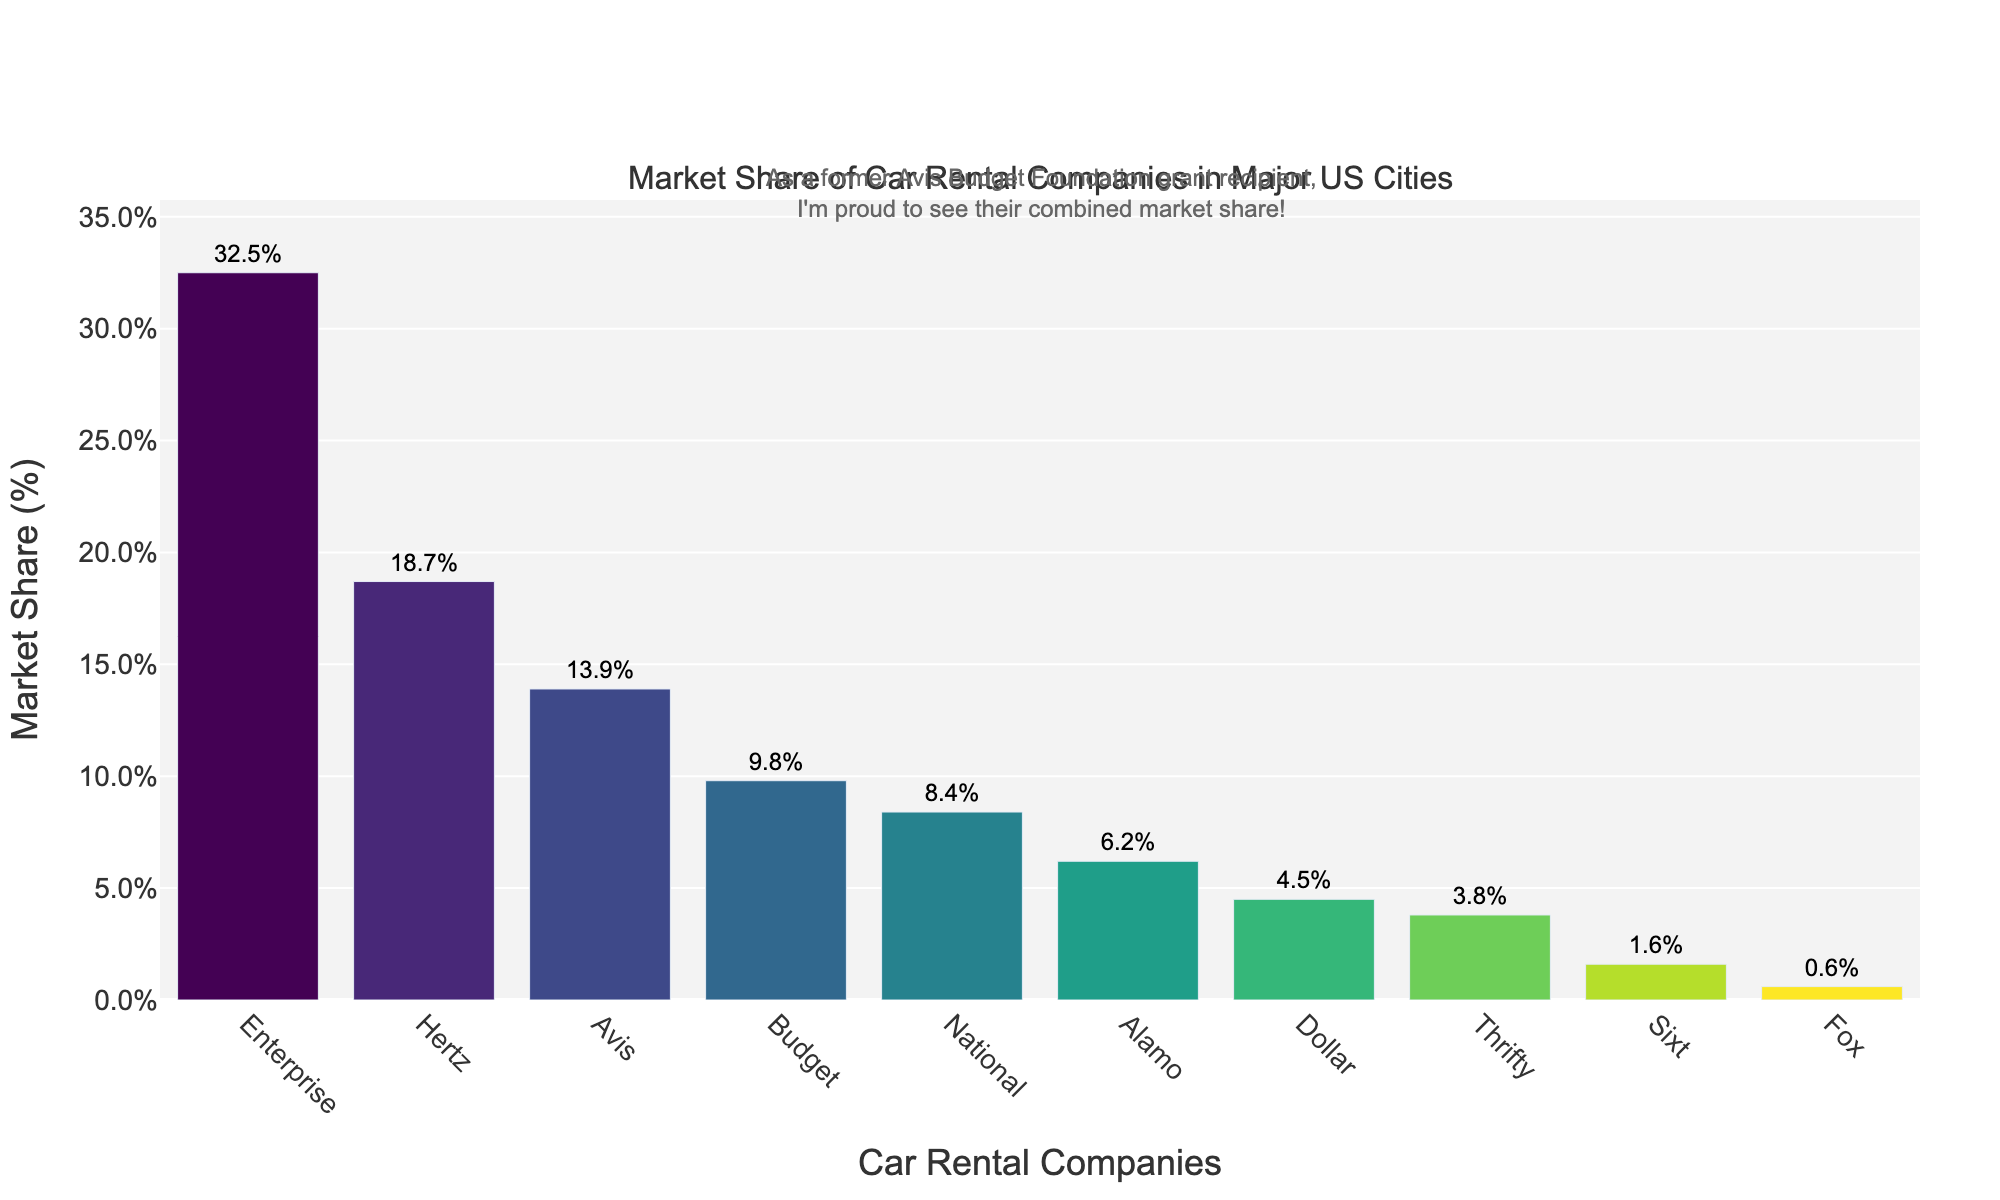Which car rental company has the highest market share? From the bar chart, the company with the tallest bar will have the highest market share. Enterprise has the tallest bar, indicating it has the highest market share.
Answer: Enterprise Which companies have a market share greater than 10%? We look at the bars that reach above the 10% mark on the y-axis. Enterprise, Hertz, and Avis have bars extending above this mark.
Answer: Enterprise, Hertz, Avis What is the combined market share of Avis and Budget? Add the market shares of Avis (13.9%) and Budget (9.8%). This gives 13.9 + 9.8 = 23.7%.
Answer: 23.7% Which company has a smaller market share, National or Alamo? Compare the height of the bars for National and Alamo. National has a taller bar (8.4%) compared to Alamo (6.2%), indicating Alamo has the smaller market share.
Answer: Alamo What is the market share difference between Hertz and Dollar? Subtract the market share of Dollar (4.5%) from Hertz (18.7%). 18.7 - 4.5 = 14.2%.
Answer: 14.2% What is the average market share of the bottom three companies? Sum the market shares of the bottom three companies (Thrifty: 3.8%, Sixt: 1.6%, Fox: 0.6%) and divide by 3. (3.8 + 1.6 + 0.6) / 3 = 2%.
Answer: 2% How many companies have a market share between 5% and 10%? Identify and count the companies within the 5% to 10% range. Budget (9.8%), National (8.4%), and Alamo (6.2%) are within this range.
Answer: 3 Which company has just over half the market share of Avis? Half of Avis's market share (13.9%) is approximately 6.95%. Alamo has 6.2%, which is just over half of Avis's share.
Answer: Alamo Is there a company with a market share under 1%? If so, which one? Look for bars that do not reach the 1% mark on the y-axis. Fox has a market share of 0.6%, which is under 1%.
Answer: Fox 